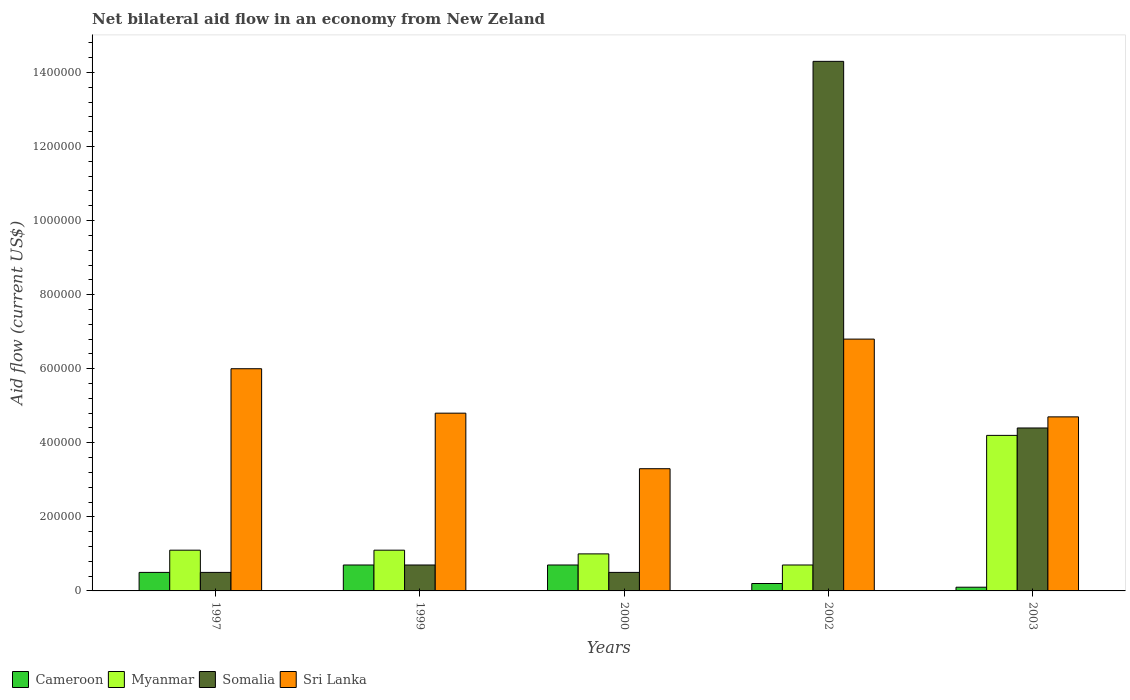How many different coloured bars are there?
Keep it short and to the point. 4. How many groups of bars are there?
Ensure brevity in your answer.  5. Are the number of bars per tick equal to the number of legend labels?
Keep it short and to the point. Yes. Are the number of bars on each tick of the X-axis equal?
Keep it short and to the point. Yes. How many bars are there on the 2nd tick from the left?
Offer a very short reply. 4. How many bars are there on the 5th tick from the right?
Give a very brief answer. 4. What is the label of the 5th group of bars from the left?
Offer a terse response. 2003. Across all years, what is the maximum net bilateral aid flow in Somalia?
Offer a terse response. 1.43e+06. Across all years, what is the minimum net bilateral aid flow in Myanmar?
Your answer should be very brief. 7.00e+04. In which year was the net bilateral aid flow in Sri Lanka maximum?
Your answer should be compact. 2002. In which year was the net bilateral aid flow in Cameroon minimum?
Make the answer very short. 2003. What is the total net bilateral aid flow in Cameroon in the graph?
Offer a terse response. 2.20e+05. What is the difference between the net bilateral aid flow in Somalia in 2000 and the net bilateral aid flow in Myanmar in 2003?
Offer a terse response. -3.70e+05. What is the average net bilateral aid flow in Somalia per year?
Give a very brief answer. 4.08e+05. In how many years, is the net bilateral aid flow in Myanmar greater than 1200000 US$?
Provide a short and direct response. 0. What is the ratio of the net bilateral aid flow in Somalia in 1999 to that in 2002?
Provide a succinct answer. 0.05. Is the difference between the net bilateral aid flow in Sri Lanka in 1997 and 1999 greater than the difference between the net bilateral aid flow in Cameroon in 1997 and 1999?
Give a very brief answer. Yes. What is the difference between the highest and the lowest net bilateral aid flow in Sri Lanka?
Your answer should be very brief. 3.50e+05. What does the 1st bar from the left in 2003 represents?
Make the answer very short. Cameroon. What does the 3rd bar from the right in 2002 represents?
Make the answer very short. Myanmar. Are all the bars in the graph horizontal?
Ensure brevity in your answer.  No. How many years are there in the graph?
Your answer should be very brief. 5. Where does the legend appear in the graph?
Offer a terse response. Bottom left. What is the title of the graph?
Ensure brevity in your answer.  Net bilateral aid flow in an economy from New Zeland. What is the label or title of the X-axis?
Provide a short and direct response. Years. What is the Aid flow (current US$) in Cameroon in 1997?
Offer a very short reply. 5.00e+04. What is the Aid flow (current US$) in Somalia in 1997?
Your answer should be very brief. 5.00e+04. What is the Aid flow (current US$) in Cameroon in 1999?
Provide a short and direct response. 7.00e+04. What is the Aid flow (current US$) in Somalia in 2000?
Your response must be concise. 5.00e+04. What is the Aid flow (current US$) of Somalia in 2002?
Provide a succinct answer. 1.43e+06. What is the Aid flow (current US$) of Sri Lanka in 2002?
Make the answer very short. 6.80e+05. What is the Aid flow (current US$) in Cameroon in 2003?
Keep it short and to the point. 10000. What is the Aid flow (current US$) in Sri Lanka in 2003?
Keep it short and to the point. 4.70e+05. Across all years, what is the maximum Aid flow (current US$) in Somalia?
Offer a very short reply. 1.43e+06. Across all years, what is the maximum Aid flow (current US$) in Sri Lanka?
Keep it short and to the point. 6.80e+05. Across all years, what is the minimum Aid flow (current US$) in Cameroon?
Keep it short and to the point. 10000. Across all years, what is the minimum Aid flow (current US$) of Myanmar?
Your response must be concise. 7.00e+04. Across all years, what is the minimum Aid flow (current US$) of Somalia?
Give a very brief answer. 5.00e+04. What is the total Aid flow (current US$) of Cameroon in the graph?
Give a very brief answer. 2.20e+05. What is the total Aid flow (current US$) in Myanmar in the graph?
Offer a terse response. 8.10e+05. What is the total Aid flow (current US$) in Somalia in the graph?
Keep it short and to the point. 2.04e+06. What is the total Aid flow (current US$) in Sri Lanka in the graph?
Keep it short and to the point. 2.56e+06. What is the difference between the Aid flow (current US$) in Myanmar in 1997 and that in 1999?
Provide a succinct answer. 0. What is the difference between the Aid flow (current US$) of Somalia in 1997 and that in 1999?
Offer a very short reply. -2.00e+04. What is the difference between the Aid flow (current US$) in Sri Lanka in 1997 and that in 1999?
Ensure brevity in your answer.  1.20e+05. What is the difference between the Aid flow (current US$) of Cameroon in 1997 and that in 2000?
Your response must be concise. -2.00e+04. What is the difference between the Aid flow (current US$) of Myanmar in 1997 and that in 2000?
Your answer should be very brief. 10000. What is the difference between the Aid flow (current US$) in Cameroon in 1997 and that in 2002?
Ensure brevity in your answer.  3.00e+04. What is the difference between the Aid flow (current US$) of Myanmar in 1997 and that in 2002?
Offer a very short reply. 4.00e+04. What is the difference between the Aid flow (current US$) in Somalia in 1997 and that in 2002?
Your response must be concise. -1.38e+06. What is the difference between the Aid flow (current US$) of Sri Lanka in 1997 and that in 2002?
Your response must be concise. -8.00e+04. What is the difference between the Aid flow (current US$) of Cameroon in 1997 and that in 2003?
Offer a very short reply. 4.00e+04. What is the difference between the Aid flow (current US$) of Myanmar in 1997 and that in 2003?
Your answer should be very brief. -3.10e+05. What is the difference between the Aid flow (current US$) in Somalia in 1997 and that in 2003?
Offer a very short reply. -3.90e+05. What is the difference between the Aid flow (current US$) of Cameroon in 1999 and that in 2000?
Provide a succinct answer. 0. What is the difference between the Aid flow (current US$) of Myanmar in 1999 and that in 2000?
Give a very brief answer. 10000. What is the difference between the Aid flow (current US$) in Somalia in 1999 and that in 2002?
Make the answer very short. -1.36e+06. What is the difference between the Aid flow (current US$) in Cameroon in 1999 and that in 2003?
Your response must be concise. 6.00e+04. What is the difference between the Aid flow (current US$) of Myanmar in 1999 and that in 2003?
Your answer should be very brief. -3.10e+05. What is the difference between the Aid flow (current US$) in Somalia in 1999 and that in 2003?
Provide a short and direct response. -3.70e+05. What is the difference between the Aid flow (current US$) of Cameroon in 2000 and that in 2002?
Ensure brevity in your answer.  5.00e+04. What is the difference between the Aid flow (current US$) in Somalia in 2000 and that in 2002?
Your response must be concise. -1.38e+06. What is the difference between the Aid flow (current US$) of Sri Lanka in 2000 and that in 2002?
Ensure brevity in your answer.  -3.50e+05. What is the difference between the Aid flow (current US$) in Myanmar in 2000 and that in 2003?
Ensure brevity in your answer.  -3.20e+05. What is the difference between the Aid flow (current US$) of Somalia in 2000 and that in 2003?
Ensure brevity in your answer.  -3.90e+05. What is the difference between the Aid flow (current US$) of Cameroon in 2002 and that in 2003?
Your answer should be very brief. 10000. What is the difference between the Aid flow (current US$) of Myanmar in 2002 and that in 2003?
Your response must be concise. -3.50e+05. What is the difference between the Aid flow (current US$) in Somalia in 2002 and that in 2003?
Keep it short and to the point. 9.90e+05. What is the difference between the Aid flow (current US$) of Cameroon in 1997 and the Aid flow (current US$) of Myanmar in 1999?
Keep it short and to the point. -6.00e+04. What is the difference between the Aid flow (current US$) of Cameroon in 1997 and the Aid flow (current US$) of Somalia in 1999?
Make the answer very short. -2.00e+04. What is the difference between the Aid flow (current US$) in Cameroon in 1997 and the Aid flow (current US$) in Sri Lanka in 1999?
Your response must be concise. -4.30e+05. What is the difference between the Aid flow (current US$) in Myanmar in 1997 and the Aid flow (current US$) in Sri Lanka in 1999?
Offer a terse response. -3.70e+05. What is the difference between the Aid flow (current US$) of Somalia in 1997 and the Aid flow (current US$) of Sri Lanka in 1999?
Your response must be concise. -4.30e+05. What is the difference between the Aid flow (current US$) of Cameroon in 1997 and the Aid flow (current US$) of Myanmar in 2000?
Provide a short and direct response. -5.00e+04. What is the difference between the Aid flow (current US$) of Cameroon in 1997 and the Aid flow (current US$) of Somalia in 2000?
Give a very brief answer. 0. What is the difference between the Aid flow (current US$) in Cameroon in 1997 and the Aid flow (current US$) in Sri Lanka in 2000?
Ensure brevity in your answer.  -2.80e+05. What is the difference between the Aid flow (current US$) in Somalia in 1997 and the Aid flow (current US$) in Sri Lanka in 2000?
Your answer should be compact. -2.80e+05. What is the difference between the Aid flow (current US$) of Cameroon in 1997 and the Aid flow (current US$) of Somalia in 2002?
Provide a short and direct response. -1.38e+06. What is the difference between the Aid flow (current US$) of Cameroon in 1997 and the Aid flow (current US$) of Sri Lanka in 2002?
Provide a short and direct response. -6.30e+05. What is the difference between the Aid flow (current US$) of Myanmar in 1997 and the Aid flow (current US$) of Somalia in 2002?
Your answer should be very brief. -1.32e+06. What is the difference between the Aid flow (current US$) in Myanmar in 1997 and the Aid flow (current US$) in Sri Lanka in 2002?
Your answer should be compact. -5.70e+05. What is the difference between the Aid flow (current US$) of Somalia in 1997 and the Aid flow (current US$) of Sri Lanka in 2002?
Keep it short and to the point. -6.30e+05. What is the difference between the Aid flow (current US$) in Cameroon in 1997 and the Aid flow (current US$) in Myanmar in 2003?
Keep it short and to the point. -3.70e+05. What is the difference between the Aid flow (current US$) in Cameroon in 1997 and the Aid flow (current US$) in Somalia in 2003?
Your answer should be very brief. -3.90e+05. What is the difference between the Aid flow (current US$) of Cameroon in 1997 and the Aid flow (current US$) of Sri Lanka in 2003?
Ensure brevity in your answer.  -4.20e+05. What is the difference between the Aid flow (current US$) in Myanmar in 1997 and the Aid flow (current US$) in Somalia in 2003?
Keep it short and to the point. -3.30e+05. What is the difference between the Aid flow (current US$) of Myanmar in 1997 and the Aid flow (current US$) of Sri Lanka in 2003?
Your answer should be very brief. -3.60e+05. What is the difference between the Aid flow (current US$) of Somalia in 1997 and the Aid flow (current US$) of Sri Lanka in 2003?
Ensure brevity in your answer.  -4.20e+05. What is the difference between the Aid flow (current US$) in Cameroon in 1999 and the Aid flow (current US$) in Myanmar in 2000?
Make the answer very short. -3.00e+04. What is the difference between the Aid flow (current US$) in Cameroon in 1999 and the Aid flow (current US$) in Somalia in 2000?
Offer a very short reply. 2.00e+04. What is the difference between the Aid flow (current US$) of Cameroon in 1999 and the Aid flow (current US$) of Sri Lanka in 2000?
Provide a succinct answer. -2.60e+05. What is the difference between the Aid flow (current US$) in Myanmar in 1999 and the Aid flow (current US$) in Sri Lanka in 2000?
Give a very brief answer. -2.20e+05. What is the difference between the Aid flow (current US$) of Cameroon in 1999 and the Aid flow (current US$) of Somalia in 2002?
Provide a short and direct response. -1.36e+06. What is the difference between the Aid flow (current US$) in Cameroon in 1999 and the Aid flow (current US$) in Sri Lanka in 2002?
Offer a very short reply. -6.10e+05. What is the difference between the Aid flow (current US$) in Myanmar in 1999 and the Aid flow (current US$) in Somalia in 2002?
Make the answer very short. -1.32e+06. What is the difference between the Aid flow (current US$) in Myanmar in 1999 and the Aid flow (current US$) in Sri Lanka in 2002?
Offer a terse response. -5.70e+05. What is the difference between the Aid flow (current US$) of Somalia in 1999 and the Aid flow (current US$) of Sri Lanka in 2002?
Offer a terse response. -6.10e+05. What is the difference between the Aid flow (current US$) of Cameroon in 1999 and the Aid flow (current US$) of Myanmar in 2003?
Provide a succinct answer. -3.50e+05. What is the difference between the Aid flow (current US$) of Cameroon in 1999 and the Aid flow (current US$) of Somalia in 2003?
Give a very brief answer. -3.70e+05. What is the difference between the Aid flow (current US$) in Cameroon in 1999 and the Aid flow (current US$) in Sri Lanka in 2003?
Provide a short and direct response. -4.00e+05. What is the difference between the Aid flow (current US$) of Myanmar in 1999 and the Aid flow (current US$) of Somalia in 2003?
Keep it short and to the point. -3.30e+05. What is the difference between the Aid flow (current US$) in Myanmar in 1999 and the Aid flow (current US$) in Sri Lanka in 2003?
Keep it short and to the point. -3.60e+05. What is the difference between the Aid flow (current US$) in Somalia in 1999 and the Aid flow (current US$) in Sri Lanka in 2003?
Provide a short and direct response. -4.00e+05. What is the difference between the Aid flow (current US$) of Cameroon in 2000 and the Aid flow (current US$) of Somalia in 2002?
Ensure brevity in your answer.  -1.36e+06. What is the difference between the Aid flow (current US$) in Cameroon in 2000 and the Aid flow (current US$) in Sri Lanka in 2002?
Make the answer very short. -6.10e+05. What is the difference between the Aid flow (current US$) in Myanmar in 2000 and the Aid flow (current US$) in Somalia in 2002?
Give a very brief answer. -1.33e+06. What is the difference between the Aid flow (current US$) of Myanmar in 2000 and the Aid flow (current US$) of Sri Lanka in 2002?
Your response must be concise. -5.80e+05. What is the difference between the Aid flow (current US$) of Somalia in 2000 and the Aid flow (current US$) of Sri Lanka in 2002?
Offer a terse response. -6.30e+05. What is the difference between the Aid flow (current US$) in Cameroon in 2000 and the Aid flow (current US$) in Myanmar in 2003?
Offer a very short reply. -3.50e+05. What is the difference between the Aid flow (current US$) in Cameroon in 2000 and the Aid flow (current US$) in Somalia in 2003?
Your answer should be compact. -3.70e+05. What is the difference between the Aid flow (current US$) of Cameroon in 2000 and the Aid flow (current US$) of Sri Lanka in 2003?
Your response must be concise. -4.00e+05. What is the difference between the Aid flow (current US$) of Myanmar in 2000 and the Aid flow (current US$) of Sri Lanka in 2003?
Offer a very short reply. -3.70e+05. What is the difference between the Aid flow (current US$) in Somalia in 2000 and the Aid flow (current US$) in Sri Lanka in 2003?
Keep it short and to the point. -4.20e+05. What is the difference between the Aid flow (current US$) of Cameroon in 2002 and the Aid flow (current US$) of Myanmar in 2003?
Offer a terse response. -4.00e+05. What is the difference between the Aid flow (current US$) in Cameroon in 2002 and the Aid flow (current US$) in Somalia in 2003?
Offer a terse response. -4.20e+05. What is the difference between the Aid flow (current US$) of Cameroon in 2002 and the Aid flow (current US$) of Sri Lanka in 2003?
Provide a succinct answer. -4.50e+05. What is the difference between the Aid flow (current US$) in Myanmar in 2002 and the Aid flow (current US$) in Somalia in 2003?
Your answer should be compact. -3.70e+05. What is the difference between the Aid flow (current US$) of Myanmar in 2002 and the Aid flow (current US$) of Sri Lanka in 2003?
Provide a succinct answer. -4.00e+05. What is the difference between the Aid flow (current US$) in Somalia in 2002 and the Aid flow (current US$) in Sri Lanka in 2003?
Your answer should be very brief. 9.60e+05. What is the average Aid flow (current US$) of Cameroon per year?
Make the answer very short. 4.40e+04. What is the average Aid flow (current US$) in Myanmar per year?
Give a very brief answer. 1.62e+05. What is the average Aid flow (current US$) of Somalia per year?
Provide a succinct answer. 4.08e+05. What is the average Aid flow (current US$) of Sri Lanka per year?
Make the answer very short. 5.12e+05. In the year 1997, what is the difference between the Aid flow (current US$) in Cameroon and Aid flow (current US$) in Sri Lanka?
Your answer should be very brief. -5.50e+05. In the year 1997, what is the difference between the Aid flow (current US$) in Myanmar and Aid flow (current US$) in Sri Lanka?
Your response must be concise. -4.90e+05. In the year 1997, what is the difference between the Aid flow (current US$) in Somalia and Aid flow (current US$) in Sri Lanka?
Offer a very short reply. -5.50e+05. In the year 1999, what is the difference between the Aid flow (current US$) of Cameroon and Aid flow (current US$) of Myanmar?
Provide a succinct answer. -4.00e+04. In the year 1999, what is the difference between the Aid flow (current US$) of Cameroon and Aid flow (current US$) of Somalia?
Your answer should be compact. 0. In the year 1999, what is the difference between the Aid flow (current US$) in Cameroon and Aid flow (current US$) in Sri Lanka?
Give a very brief answer. -4.10e+05. In the year 1999, what is the difference between the Aid flow (current US$) in Myanmar and Aid flow (current US$) in Sri Lanka?
Offer a terse response. -3.70e+05. In the year 1999, what is the difference between the Aid flow (current US$) of Somalia and Aid flow (current US$) of Sri Lanka?
Your answer should be very brief. -4.10e+05. In the year 2000, what is the difference between the Aid flow (current US$) in Myanmar and Aid flow (current US$) in Sri Lanka?
Provide a succinct answer. -2.30e+05. In the year 2000, what is the difference between the Aid flow (current US$) of Somalia and Aid flow (current US$) of Sri Lanka?
Your response must be concise. -2.80e+05. In the year 2002, what is the difference between the Aid flow (current US$) of Cameroon and Aid flow (current US$) of Somalia?
Make the answer very short. -1.41e+06. In the year 2002, what is the difference between the Aid flow (current US$) in Cameroon and Aid flow (current US$) in Sri Lanka?
Your answer should be very brief. -6.60e+05. In the year 2002, what is the difference between the Aid flow (current US$) of Myanmar and Aid flow (current US$) of Somalia?
Offer a terse response. -1.36e+06. In the year 2002, what is the difference between the Aid flow (current US$) of Myanmar and Aid flow (current US$) of Sri Lanka?
Give a very brief answer. -6.10e+05. In the year 2002, what is the difference between the Aid flow (current US$) of Somalia and Aid flow (current US$) of Sri Lanka?
Offer a very short reply. 7.50e+05. In the year 2003, what is the difference between the Aid flow (current US$) of Cameroon and Aid flow (current US$) of Myanmar?
Your answer should be very brief. -4.10e+05. In the year 2003, what is the difference between the Aid flow (current US$) in Cameroon and Aid flow (current US$) in Somalia?
Make the answer very short. -4.30e+05. In the year 2003, what is the difference between the Aid flow (current US$) in Cameroon and Aid flow (current US$) in Sri Lanka?
Keep it short and to the point. -4.60e+05. In the year 2003, what is the difference between the Aid flow (current US$) of Myanmar and Aid flow (current US$) of Sri Lanka?
Your answer should be very brief. -5.00e+04. What is the ratio of the Aid flow (current US$) in Myanmar in 1997 to that in 1999?
Your answer should be compact. 1. What is the ratio of the Aid flow (current US$) in Somalia in 1997 to that in 1999?
Offer a very short reply. 0.71. What is the ratio of the Aid flow (current US$) of Myanmar in 1997 to that in 2000?
Offer a very short reply. 1.1. What is the ratio of the Aid flow (current US$) in Somalia in 1997 to that in 2000?
Give a very brief answer. 1. What is the ratio of the Aid flow (current US$) of Sri Lanka in 1997 to that in 2000?
Ensure brevity in your answer.  1.82. What is the ratio of the Aid flow (current US$) of Cameroon in 1997 to that in 2002?
Offer a very short reply. 2.5. What is the ratio of the Aid flow (current US$) of Myanmar in 1997 to that in 2002?
Ensure brevity in your answer.  1.57. What is the ratio of the Aid flow (current US$) of Somalia in 1997 to that in 2002?
Your response must be concise. 0.04. What is the ratio of the Aid flow (current US$) in Sri Lanka in 1997 to that in 2002?
Provide a succinct answer. 0.88. What is the ratio of the Aid flow (current US$) of Cameroon in 1997 to that in 2003?
Give a very brief answer. 5. What is the ratio of the Aid flow (current US$) of Myanmar in 1997 to that in 2003?
Your response must be concise. 0.26. What is the ratio of the Aid flow (current US$) in Somalia in 1997 to that in 2003?
Offer a very short reply. 0.11. What is the ratio of the Aid flow (current US$) in Sri Lanka in 1997 to that in 2003?
Provide a succinct answer. 1.28. What is the ratio of the Aid flow (current US$) in Sri Lanka in 1999 to that in 2000?
Offer a very short reply. 1.45. What is the ratio of the Aid flow (current US$) of Cameroon in 1999 to that in 2002?
Your response must be concise. 3.5. What is the ratio of the Aid flow (current US$) in Myanmar in 1999 to that in 2002?
Provide a succinct answer. 1.57. What is the ratio of the Aid flow (current US$) in Somalia in 1999 to that in 2002?
Offer a terse response. 0.05. What is the ratio of the Aid flow (current US$) of Sri Lanka in 1999 to that in 2002?
Provide a succinct answer. 0.71. What is the ratio of the Aid flow (current US$) in Cameroon in 1999 to that in 2003?
Make the answer very short. 7. What is the ratio of the Aid flow (current US$) of Myanmar in 1999 to that in 2003?
Give a very brief answer. 0.26. What is the ratio of the Aid flow (current US$) of Somalia in 1999 to that in 2003?
Offer a terse response. 0.16. What is the ratio of the Aid flow (current US$) in Sri Lanka in 1999 to that in 2003?
Offer a terse response. 1.02. What is the ratio of the Aid flow (current US$) of Myanmar in 2000 to that in 2002?
Keep it short and to the point. 1.43. What is the ratio of the Aid flow (current US$) in Somalia in 2000 to that in 2002?
Ensure brevity in your answer.  0.04. What is the ratio of the Aid flow (current US$) in Sri Lanka in 2000 to that in 2002?
Offer a very short reply. 0.49. What is the ratio of the Aid flow (current US$) in Cameroon in 2000 to that in 2003?
Offer a terse response. 7. What is the ratio of the Aid flow (current US$) of Myanmar in 2000 to that in 2003?
Ensure brevity in your answer.  0.24. What is the ratio of the Aid flow (current US$) of Somalia in 2000 to that in 2003?
Provide a short and direct response. 0.11. What is the ratio of the Aid flow (current US$) in Sri Lanka in 2000 to that in 2003?
Your answer should be compact. 0.7. What is the ratio of the Aid flow (current US$) in Cameroon in 2002 to that in 2003?
Your answer should be very brief. 2. What is the ratio of the Aid flow (current US$) of Myanmar in 2002 to that in 2003?
Your answer should be very brief. 0.17. What is the ratio of the Aid flow (current US$) in Sri Lanka in 2002 to that in 2003?
Your answer should be very brief. 1.45. What is the difference between the highest and the second highest Aid flow (current US$) in Myanmar?
Your answer should be very brief. 3.10e+05. What is the difference between the highest and the second highest Aid flow (current US$) in Somalia?
Provide a short and direct response. 9.90e+05. What is the difference between the highest and the second highest Aid flow (current US$) in Sri Lanka?
Your response must be concise. 8.00e+04. What is the difference between the highest and the lowest Aid flow (current US$) in Myanmar?
Your answer should be very brief. 3.50e+05. What is the difference between the highest and the lowest Aid flow (current US$) of Somalia?
Offer a very short reply. 1.38e+06. What is the difference between the highest and the lowest Aid flow (current US$) in Sri Lanka?
Provide a short and direct response. 3.50e+05. 